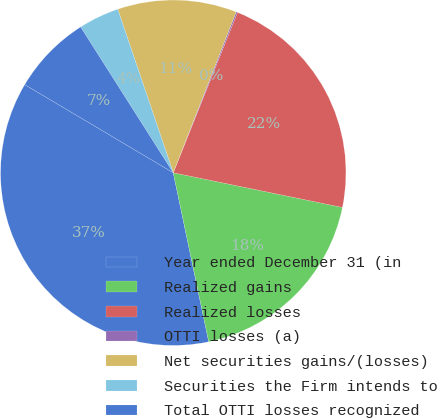Convert chart to OTSL. <chart><loc_0><loc_0><loc_500><loc_500><pie_chart><fcel>Year ended December 31 (in<fcel>Realized gains<fcel>Realized losses<fcel>OTTI losses (a)<fcel>Net securities gains/(losses)<fcel>Securities the Firm intends to<fcel>Total OTTI losses recognized<nl><fcel>36.82%<fcel>18.49%<fcel>22.16%<fcel>0.13%<fcel>11.14%<fcel>3.8%<fcel>7.47%<nl></chart> 